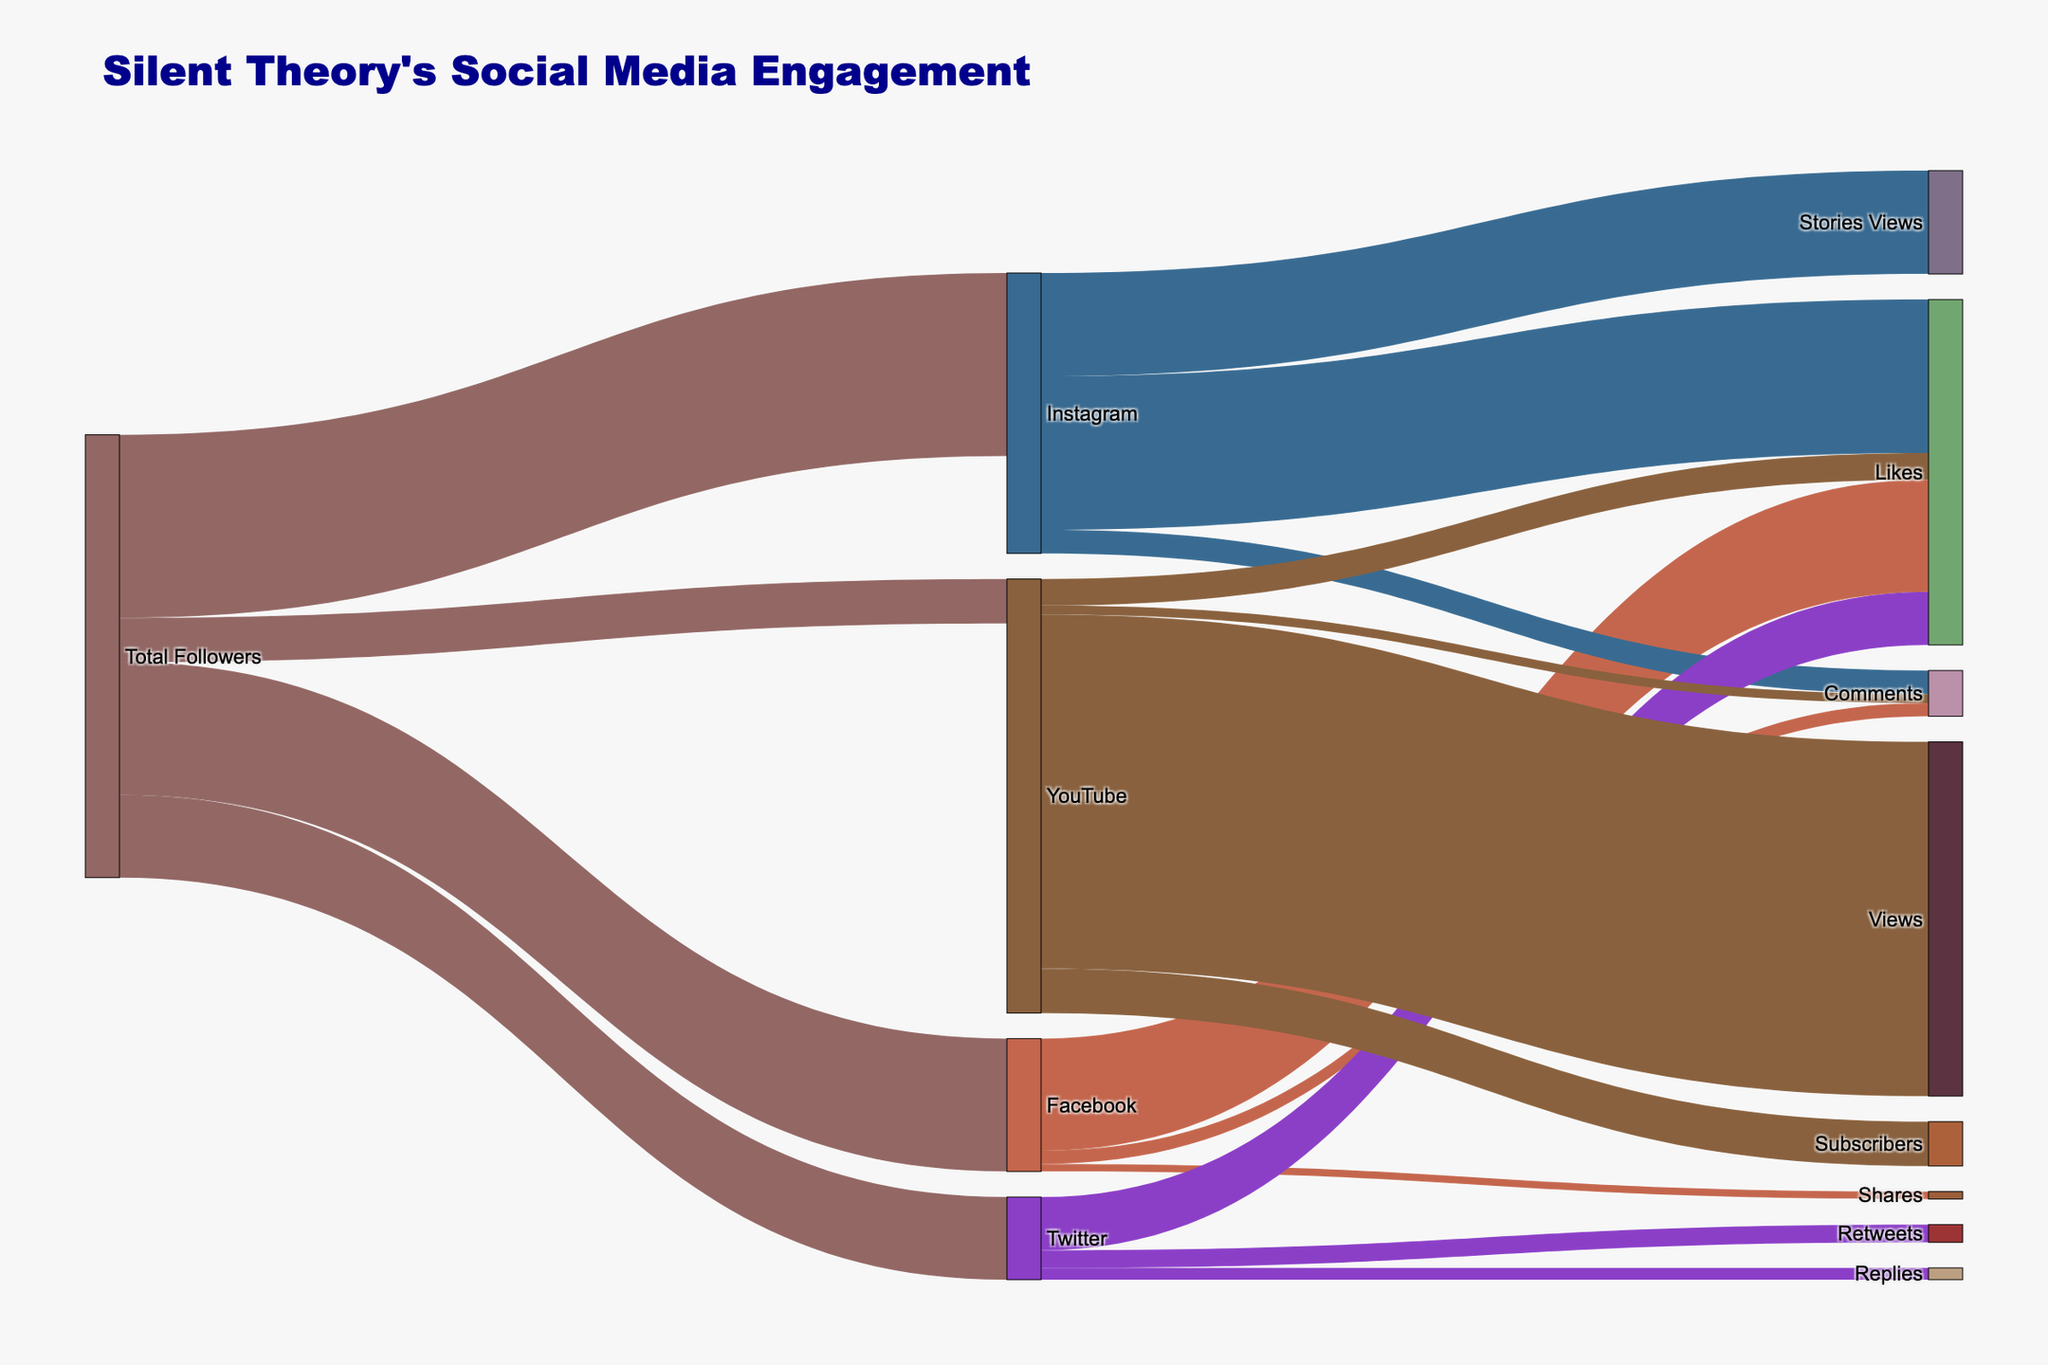what is the title of the figure? The title of the figure is shown at the top, usually in a larger and bold font. It summarizes the main content of the diagram.
Answer: Silent Theory's Social Media Engagement how many followers does Silent Theory have on Instagram? The number of followers for each platform is shown flowing from 'Total Followers' to individual platforms, with the respective follower count indicated. instagram is one of those targets.
Answer: 62000 how does the engagement on Facebook compare to that on Twitter in terms of likes? For this, observe the paths flowing from 'Facebook' and 'Twitter' to 'Likes'. Compare the numbers displayed on each path.
Answer: Facebook: 38000, Twitter: 18000 which engagement type has the highest value on YouTube? Look at the connections from 'YouTube' to different engagement types, such as Views, Likes, Comments, and Subscribers, and compare their counts.
Answer: Views what is the total number of YouTube engagements? Add up the values of different engagement types flowing out from 'YouTube': Views, Likes, Comments, and Subscribers.
Answer: 147000 what is the total amount of Likes across all platforms? Sum the values flowing from each platform to 'Likes': Facebook, Instagram, Twitter, and YouTube.
Answer: 127000 are there more comments on Instagram or Facebook? Compare the values flowing from 'Instagram' and 'Facebook' to 'Comments'.
Answer: Instagram how many followers does Silent Theory have across all social media platforms? Add up the values from 'Total Followers' flowing to each platform: Facebook, Instagram, Twitter, and YouTube.
Answer: 150000 which platform has the least number of followers? Compare the follower counts directly flowing from 'Total Followers' to each platform. The platform with the smallest number is the answer.
Answer: YouTube what is the ratio of YouTube views to YouTube subscribers? Divide the count for YouTube 'Views' by the count for YouTube 'Subscribers' for the ratio.
Answer: 8:1 